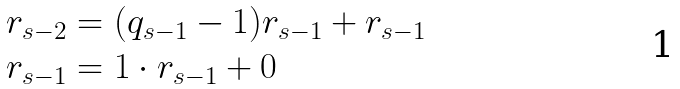Convert formula to latex. <formula><loc_0><loc_0><loc_500><loc_500>r _ { s - 2 } & = ( q _ { s - 1 } - 1 ) r _ { s - 1 } + r _ { s - 1 } \\ r _ { s - 1 } & = 1 \cdot r _ { s - 1 } + 0</formula> 